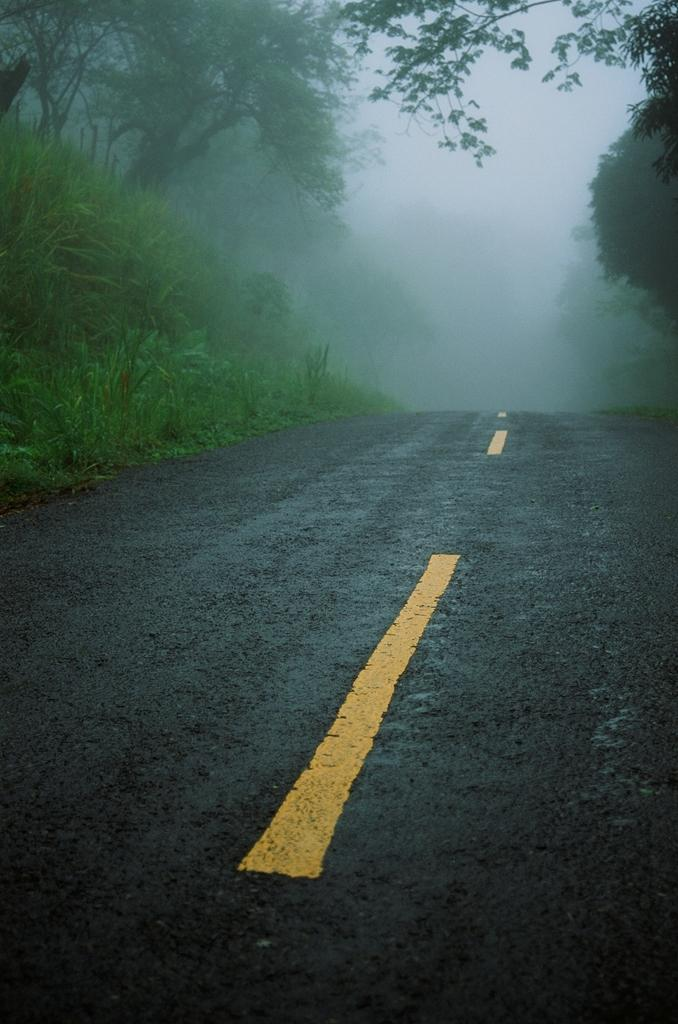What is the main feature of the image? There is a road in the image. What else can be seen on the ground in the image? There are plants on the ground in the image. What type of vegetation is visible in the image? There are trees visible in the image. What type of disgust can be seen on the road in the image? There is no indication of disgust in the image; it features a road, plants, and trees. Can you tell me how many vases are present in the image? There are no vases present in the image. 